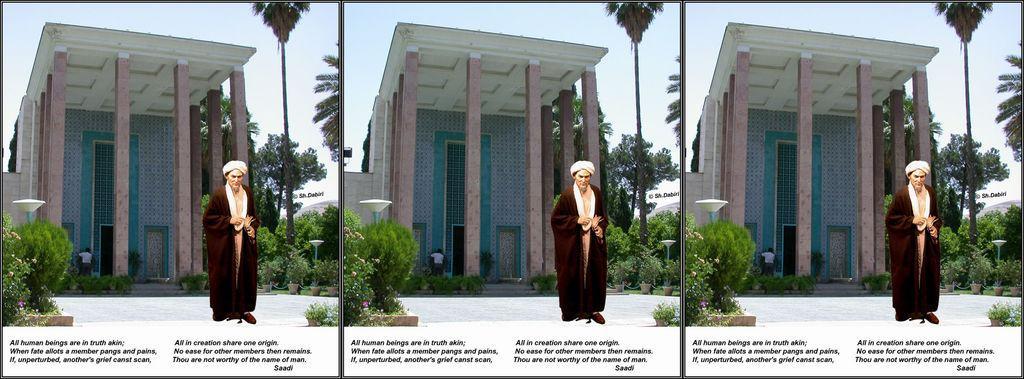Could you give a brief overview of what you see in this image? This is the collage of three same images where there is a person, a building, few trees, garden plants, objects at the top of the poles and the sky. 